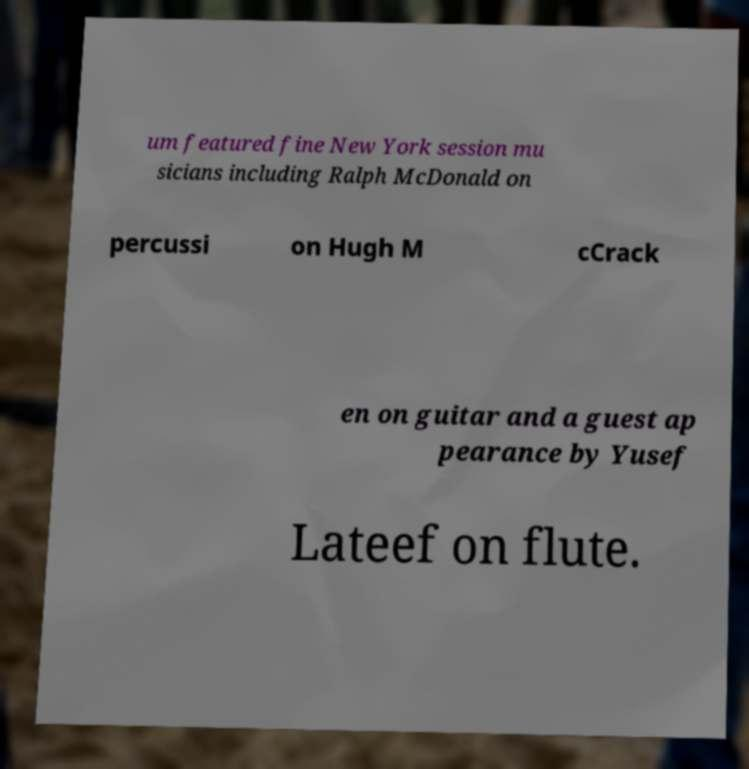Could you extract and type out the text from this image? um featured fine New York session mu sicians including Ralph McDonald on percussi on Hugh M cCrack en on guitar and a guest ap pearance by Yusef Lateef on flute. 